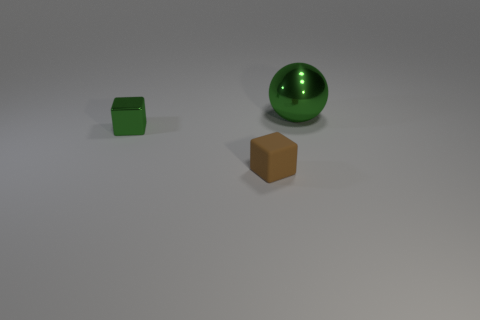Is there anything else that is the same shape as the large shiny object?
Make the answer very short. No. How many spheres are either large gray things or small brown rubber objects?
Your response must be concise. 0. How big is the thing that is in front of the big green shiny ball and right of the green cube?
Your answer should be compact. Small. What number of other things are the same color as the tiny shiny block?
Your response must be concise. 1. Is the material of the ball the same as the green object in front of the shiny sphere?
Offer a terse response. Yes. How many things are tiny cubes that are left of the small brown object or brown rubber things?
Make the answer very short. 2. There is a object that is both to the right of the small metallic block and to the left of the shiny ball; what is its shape?
Offer a very short reply. Cube. Is there any other thing that is the same size as the green metal block?
Offer a terse response. Yes. The green thing that is the same material as the green block is what size?
Your answer should be very brief. Large. What number of objects are either things in front of the green metal ball or objects behind the tiny matte block?
Give a very brief answer. 3. 